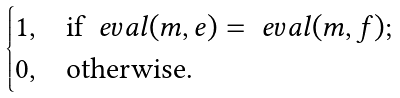<formula> <loc_0><loc_0><loc_500><loc_500>\begin{cases} 1 , & \text {if } \ e v a l ( m , e ) = \ e v a l ( m , f ) ; \\ 0 , & \text {otherwise} . \end{cases}</formula> 